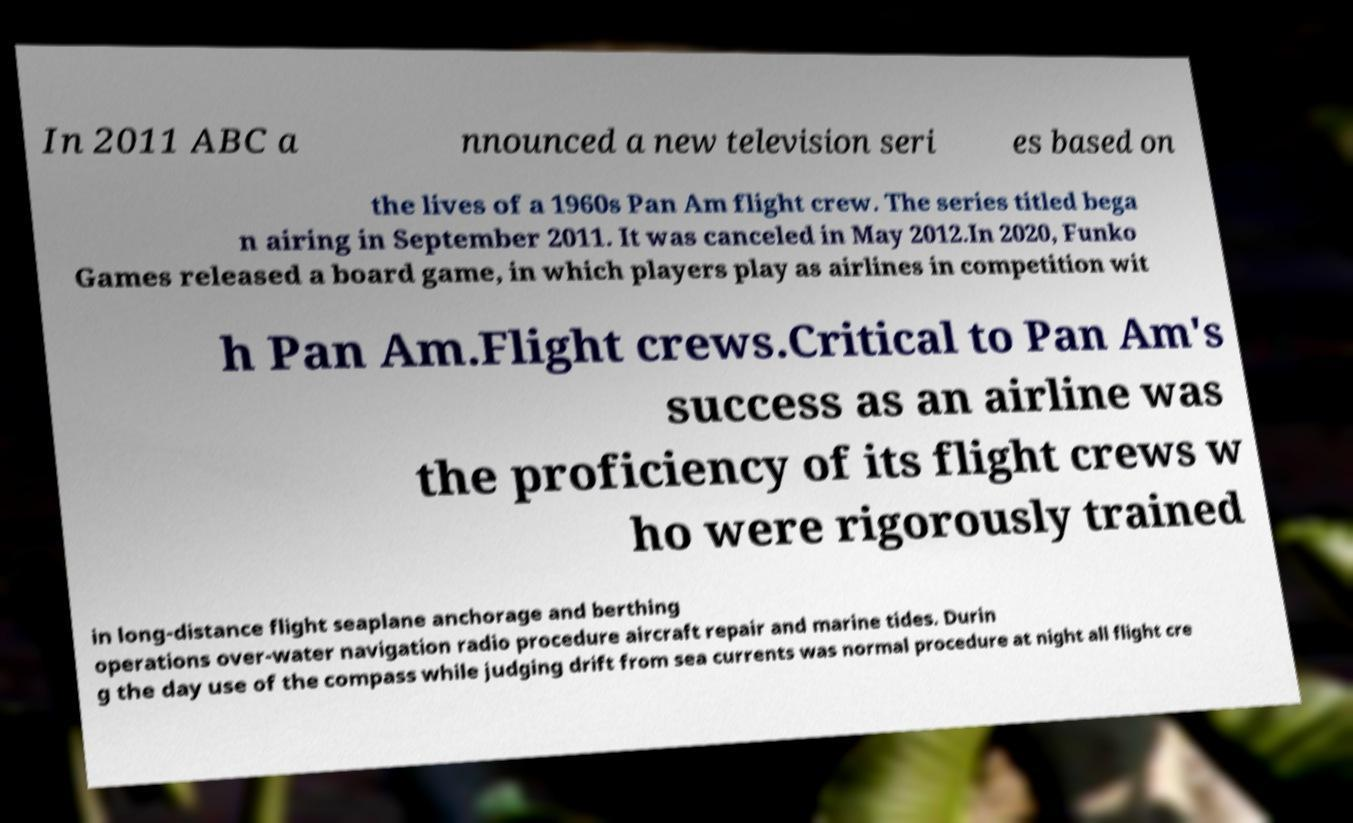For documentation purposes, I need the text within this image transcribed. Could you provide that? In 2011 ABC a nnounced a new television seri es based on the lives of a 1960s Pan Am flight crew. The series titled bega n airing in September 2011. It was canceled in May 2012.In 2020, Funko Games released a board game, in which players play as airlines in competition wit h Pan Am.Flight crews.Critical to Pan Am's success as an airline was the proficiency of its flight crews w ho were rigorously trained in long-distance flight seaplane anchorage and berthing operations over-water navigation radio procedure aircraft repair and marine tides. Durin g the day use of the compass while judging drift from sea currents was normal procedure at night all flight cre 